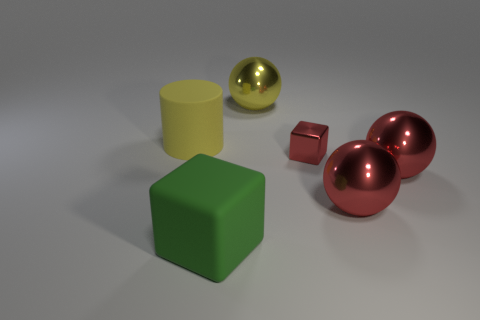What number of things are big metal objects or yellow things on the right side of the green rubber cube?
Make the answer very short. 3. Is there a large blue object of the same shape as the green rubber thing?
Offer a very short reply. No. There is a block to the right of the ball that is on the left side of the metal block; what size is it?
Keep it short and to the point. Small. Is the color of the rubber cube the same as the small shiny cube?
Provide a succinct answer. No. How many metal things are either green blocks or big red things?
Give a very brief answer. 2. How many tiny yellow balls are there?
Give a very brief answer. 0. Are the large yellow object on the left side of the yellow ball and the cube to the left of the tiny red thing made of the same material?
Make the answer very short. Yes. There is another object that is the same shape as the green matte thing; what color is it?
Ensure brevity in your answer.  Red. What is the large yellow thing that is on the left side of the metallic sphere that is behind the big yellow cylinder made of?
Make the answer very short. Rubber. There is a large yellow thing in front of the yellow metallic sphere; does it have the same shape as the shiny thing that is behind the metallic block?
Offer a terse response. No. 